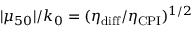<formula> <loc_0><loc_0><loc_500><loc_500>| \mu _ { 5 0 } | / k _ { 0 } = ( \eta _ { d i f f } / \eta _ { C P I } ) ^ { 1 / 2 }</formula> 